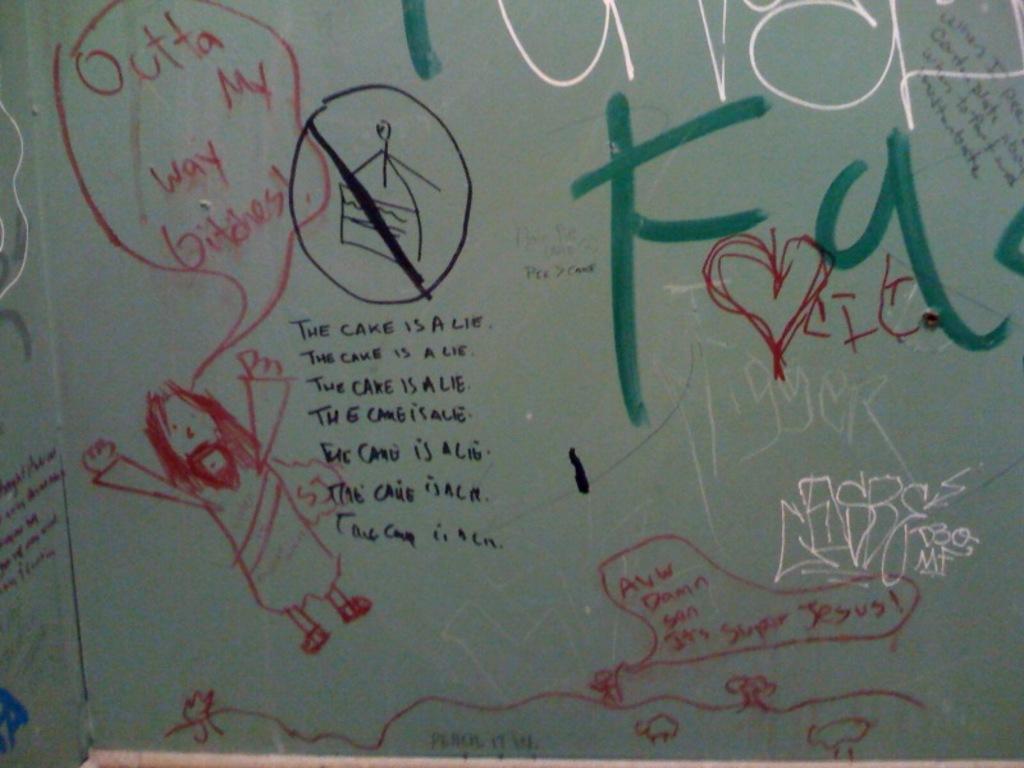In one or two sentences, can you explain what this image depicts? In this picture I can observe a wall on which there are some drawings. I can observe some text on the wall. 